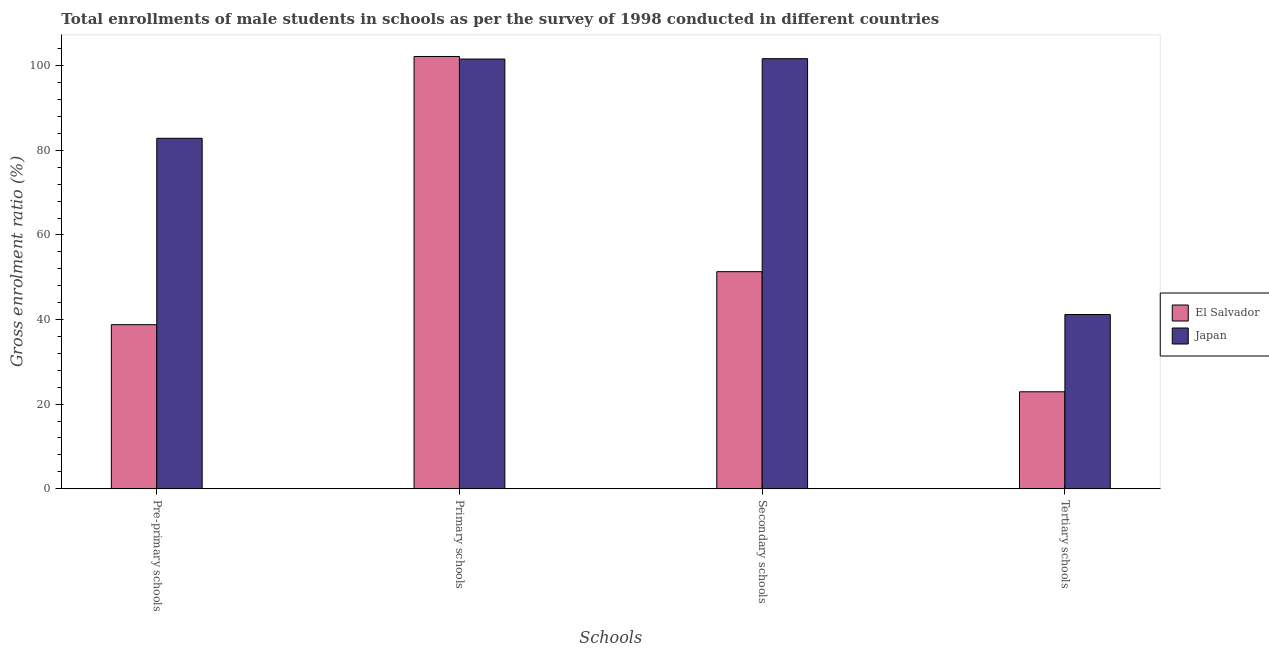How many different coloured bars are there?
Provide a succinct answer. 2. How many groups of bars are there?
Offer a terse response. 4. Are the number of bars per tick equal to the number of legend labels?
Provide a succinct answer. Yes. Are the number of bars on each tick of the X-axis equal?
Provide a succinct answer. Yes. How many bars are there on the 1st tick from the left?
Keep it short and to the point. 2. What is the label of the 4th group of bars from the left?
Make the answer very short. Tertiary schools. What is the gross enrolment ratio(male) in primary schools in El Salvador?
Your response must be concise. 102.22. Across all countries, what is the maximum gross enrolment ratio(male) in secondary schools?
Give a very brief answer. 101.7. Across all countries, what is the minimum gross enrolment ratio(male) in primary schools?
Your response must be concise. 101.61. In which country was the gross enrolment ratio(male) in secondary schools minimum?
Give a very brief answer. El Salvador. What is the total gross enrolment ratio(male) in primary schools in the graph?
Make the answer very short. 203.83. What is the difference between the gross enrolment ratio(male) in secondary schools in Japan and that in El Salvador?
Offer a very short reply. 50.37. What is the difference between the gross enrolment ratio(male) in secondary schools in El Salvador and the gross enrolment ratio(male) in primary schools in Japan?
Provide a short and direct response. -50.29. What is the average gross enrolment ratio(male) in primary schools per country?
Provide a succinct answer. 101.92. What is the difference between the gross enrolment ratio(male) in primary schools and gross enrolment ratio(male) in secondary schools in Japan?
Offer a very short reply. -0.09. What is the ratio of the gross enrolment ratio(male) in tertiary schools in Japan to that in El Salvador?
Your answer should be very brief. 1.8. Is the gross enrolment ratio(male) in primary schools in Japan less than that in El Salvador?
Offer a terse response. Yes. What is the difference between the highest and the second highest gross enrolment ratio(male) in primary schools?
Your response must be concise. 0.61. What is the difference between the highest and the lowest gross enrolment ratio(male) in pre-primary schools?
Offer a very short reply. 44.09. Is the sum of the gross enrolment ratio(male) in primary schools in Japan and El Salvador greater than the maximum gross enrolment ratio(male) in tertiary schools across all countries?
Your response must be concise. Yes. What does the 2nd bar from the left in Tertiary schools represents?
Ensure brevity in your answer.  Japan. What does the 1st bar from the right in Tertiary schools represents?
Make the answer very short. Japan. How many countries are there in the graph?
Ensure brevity in your answer.  2. Are the values on the major ticks of Y-axis written in scientific E-notation?
Offer a terse response. No. How are the legend labels stacked?
Make the answer very short. Vertical. What is the title of the graph?
Offer a terse response. Total enrollments of male students in schools as per the survey of 1998 conducted in different countries. What is the label or title of the X-axis?
Offer a terse response. Schools. What is the label or title of the Y-axis?
Provide a short and direct response. Gross enrolment ratio (%). What is the Gross enrolment ratio (%) of El Salvador in Pre-primary schools?
Ensure brevity in your answer.  38.79. What is the Gross enrolment ratio (%) of Japan in Pre-primary schools?
Make the answer very short. 82.87. What is the Gross enrolment ratio (%) in El Salvador in Primary schools?
Provide a succinct answer. 102.22. What is the Gross enrolment ratio (%) of Japan in Primary schools?
Offer a terse response. 101.61. What is the Gross enrolment ratio (%) in El Salvador in Secondary schools?
Give a very brief answer. 51.33. What is the Gross enrolment ratio (%) of Japan in Secondary schools?
Your answer should be very brief. 101.7. What is the Gross enrolment ratio (%) in El Salvador in Tertiary schools?
Your answer should be very brief. 22.92. What is the Gross enrolment ratio (%) in Japan in Tertiary schools?
Make the answer very short. 41.19. Across all Schools, what is the maximum Gross enrolment ratio (%) of El Salvador?
Your response must be concise. 102.22. Across all Schools, what is the maximum Gross enrolment ratio (%) in Japan?
Your response must be concise. 101.7. Across all Schools, what is the minimum Gross enrolment ratio (%) of El Salvador?
Offer a terse response. 22.92. Across all Schools, what is the minimum Gross enrolment ratio (%) in Japan?
Give a very brief answer. 41.19. What is the total Gross enrolment ratio (%) in El Salvador in the graph?
Provide a succinct answer. 215.25. What is the total Gross enrolment ratio (%) in Japan in the graph?
Give a very brief answer. 327.38. What is the difference between the Gross enrolment ratio (%) of El Salvador in Pre-primary schools and that in Primary schools?
Provide a short and direct response. -63.43. What is the difference between the Gross enrolment ratio (%) in Japan in Pre-primary schools and that in Primary schools?
Keep it short and to the point. -18.74. What is the difference between the Gross enrolment ratio (%) in El Salvador in Pre-primary schools and that in Secondary schools?
Your answer should be compact. -12.54. What is the difference between the Gross enrolment ratio (%) of Japan in Pre-primary schools and that in Secondary schools?
Offer a very short reply. -18.83. What is the difference between the Gross enrolment ratio (%) of El Salvador in Pre-primary schools and that in Tertiary schools?
Provide a succinct answer. 15.87. What is the difference between the Gross enrolment ratio (%) in Japan in Pre-primary schools and that in Tertiary schools?
Provide a succinct answer. 41.68. What is the difference between the Gross enrolment ratio (%) of El Salvador in Primary schools and that in Secondary schools?
Ensure brevity in your answer.  50.89. What is the difference between the Gross enrolment ratio (%) of Japan in Primary schools and that in Secondary schools?
Provide a succinct answer. -0.09. What is the difference between the Gross enrolment ratio (%) of El Salvador in Primary schools and that in Tertiary schools?
Provide a succinct answer. 79.3. What is the difference between the Gross enrolment ratio (%) in Japan in Primary schools and that in Tertiary schools?
Your response must be concise. 60.42. What is the difference between the Gross enrolment ratio (%) in El Salvador in Secondary schools and that in Tertiary schools?
Your answer should be very brief. 28.41. What is the difference between the Gross enrolment ratio (%) of Japan in Secondary schools and that in Tertiary schools?
Offer a very short reply. 60.51. What is the difference between the Gross enrolment ratio (%) of El Salvador in Pre-primary schools and the Gross enrolment ratio (%) of Japan in Primary schools?
Make the answer very short. -62.83. What is the difference between the Gross enrolment ratio (%) in El Salvador in Pre-primary schools and the Gross enrolment ratio (%) in Japan in Secondary schools?
Offer a terse response. -62.91. What is the difference between the Gross enrolment ratio (%) in El Salvador in Pre-primary schools and the Gross enrolment ratio (%) in Japan in Tertiary schools?
Your answer should be compact. -2.41. What is the difference between the Gross enrolment ratio (%) in El Salvador in Primary schools and the Gross enrolment ratio (%) in Japan in Secondary schools?
Keep it short and to the point. 0.52. What is the difference between the Gross enrolment ratio (%) of El Salvador in Primary schools and the Gross enrolment ratio (%) of Japan in Tertiary schools?
Give a very brief answer. 61.03. What is the difference between the Gross enrolment ratio (%) of El Salvador in Secondary schools and the Gross enrolment ratio (%) of Japan in Tertiary schools?
Make the answer very short. 10.13. What is the average Gross enrolment ratio (%) in El Salvador per Schools?
Provide a short and direct response. 53.81. What is the average Gross enrolment ratio (%) in Japan per Schools?
Make the answer very short. 81.84. What is the difference between the Gross enrolment ratio (%) of El Salvador and Gross enrolment ratio (%) of Japan in Pre-primary schools?
Your answer should be very brief. -44.09. What is the difference between the Gross enrolment ratio (%) of El Salvador and Gross enrolment ratio (%) of Japan in Primary schools?
Offer a terse response. 0.61. What is the difference between the Gross enrolment ratio (%) of El Salvador and Gross enrolment ratio (%) of Japan in Secondary schools?
Make the answer very short. -50.37. What is the difference between the Gross enrolment ratio (%) in El Salvador and Gross enrolment ratio (%) in Japan in Tertiary schools?
Your answer should be compact. -18.28. What is the ratio of the Gross enrolment ratio (%) in El Salvador in Pre-primary schools to that in Primary schools?
Keep it short and to the point. 0.38. What is the ratio of the Gross enrolment ratio (%) in Japan in Pre-primary schools to that in Primary schools?
Your answer should be very brief. 0.82. What is the ratio of the Gross enrolment ratio (%) in El Salvador in Pre-primary schools to that in Secondary schools?
Provide a short and direct response. 0.76. What is the ratio of the Gross enrolment ratio (%) in Japan in Pre-primary schools to that in Secondary schools?
Keep it short and to the point. 0.81. What is the ratio of the Gross enrolment ratio (%) in El Salvador in Pre-primary schools to that in Tertiary schools?
Offer a very short reply. 1.69. What is the ratio of the Gross enrolment ratio (%) of Japan in Pre-primary schools to that in Tertiary schools?
Offer a terse response. 2.01. What is the ratio of the Gross enrolment ratio (%) in El Salvador in Primary schools to that in Secondary schools?
Ensure brevity in your answer.  1.99. What is the ratio of the Gross enrolment ratio (%) in Japan in Primary schools to that in Secondary schools?
Provide a short and direct response. 1. What is the ratio of the Gross enrolment ratio (%) in El Salvador in Primary schools to that in Tertiary schools?
Offer a very short reply. 4.46. What is the ratio of the Gross enrolment ratio (%) in Japan in Primary schools to that in Tertiary schools?
Keep it short and to the point. 2.47. What is the ratio of the Gross enrolment ratio (%) of El Salvador in Secondary schools to that in Tertiary schools?
Your response must be concise. 2.24. What is the ratio of the Gross enrolment ratio (%) in Japan in Secondary schools to that in Tertiary schools?
Your answer should be compact. 2.47. What is the difference between the highest and the second highest Gross enrolment ratio (%) of El Salvador?
Offer a terse response. 50.89. What is the difference between the highest and the second highest Gross enrolment ratio (%) in Japan?
Your response must be concise. 0.09. What is the difference between the highest and the lowest Gross enrolment ratio (%) of El Salvador?
Keep it short and to the point. 79.3. What is the difference between the highest and the lowest Gross enrolment ratio (%) in Japan?
Your answer should be very brief. 60.51. 